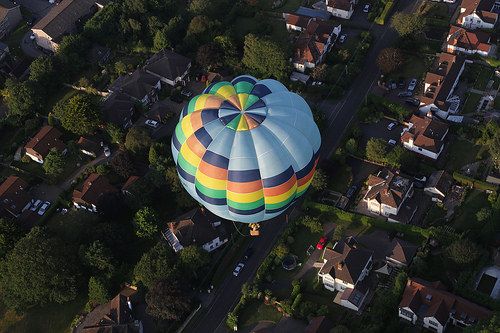<image>
Is the balloon on the ground? No. The balloon is not positioned on the ground. They may be near each other, but the balloon is not supported by or resting on top of the ground. Where is the house in relation to the balloon? Is it in front of the balloon? No. The house is not in front of the balloon. The spatial positioning shows a different relationship between these objects. 